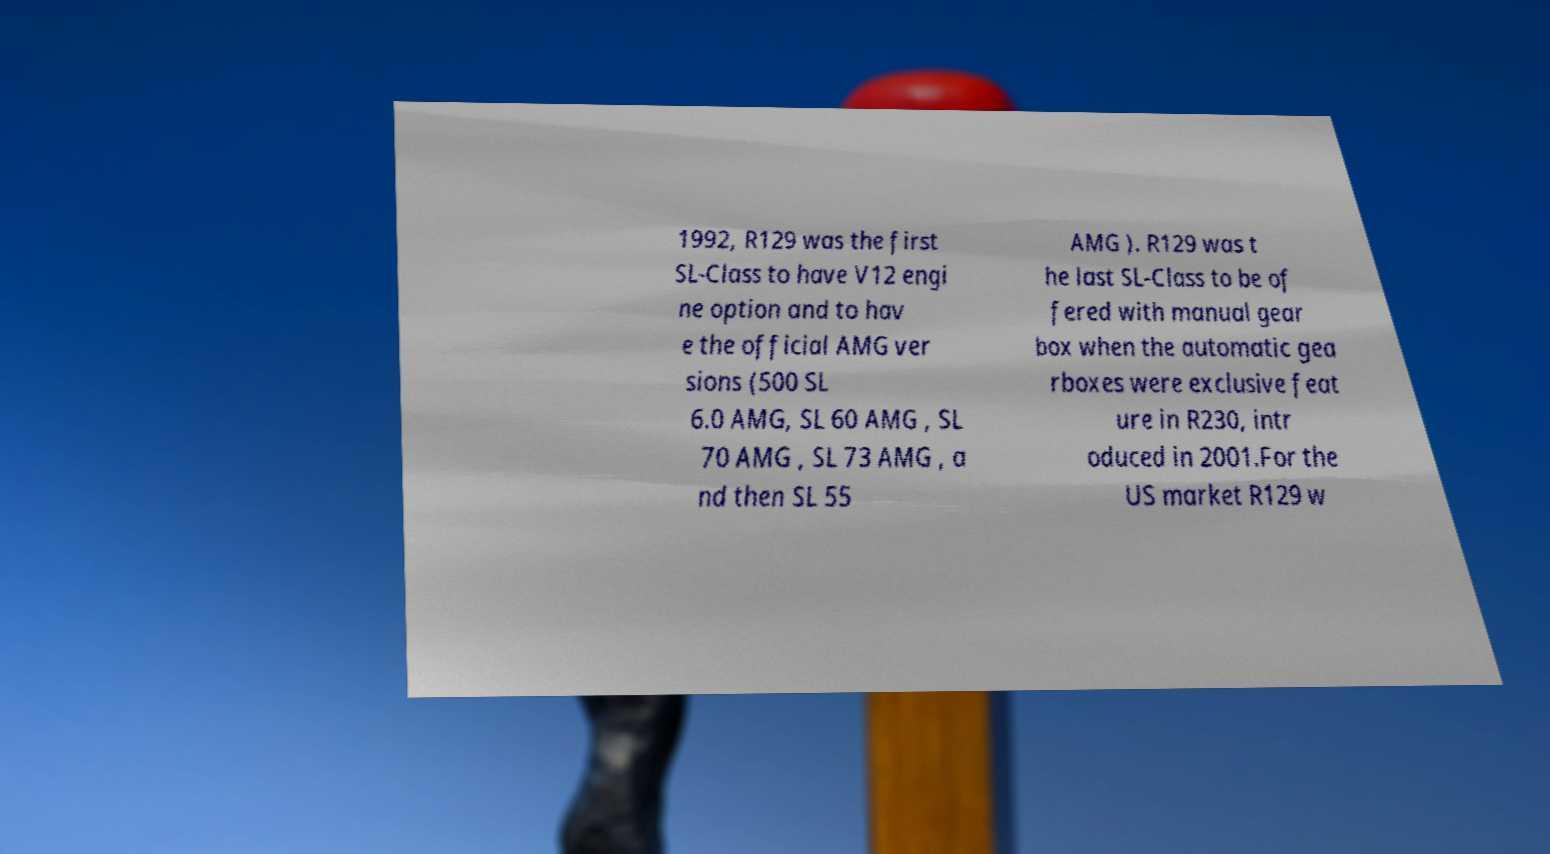For documentation purposes, I need the text within this image transcribed. Could you provide that? 1992, R129 was the first SL-Class to have V12 engi ne option and to hav e the official AMG ver sions (500 SL 6.0 AMG, SL 60 AMG , SL 70 AMG , SL 73 AMG , a nd then SL 55 AMG ). R129 was t he last SL-Class to be of fered with manual gear box when the automatic gea rboxes were exclusive feat ure in R230, intr oduced in 2001.For the US market R129 w 